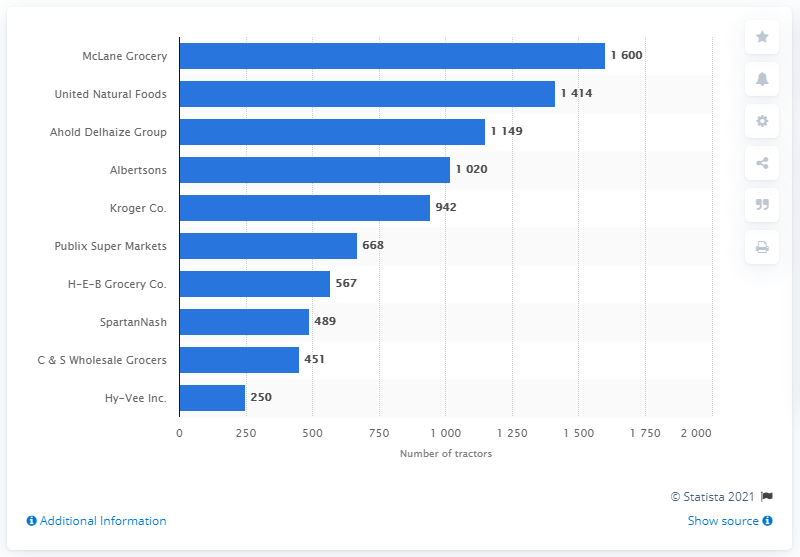Point out several critical features in this image. According to data from 2020, the private grocery freight carrier with the highest number of tractors was McLane Grocery. 